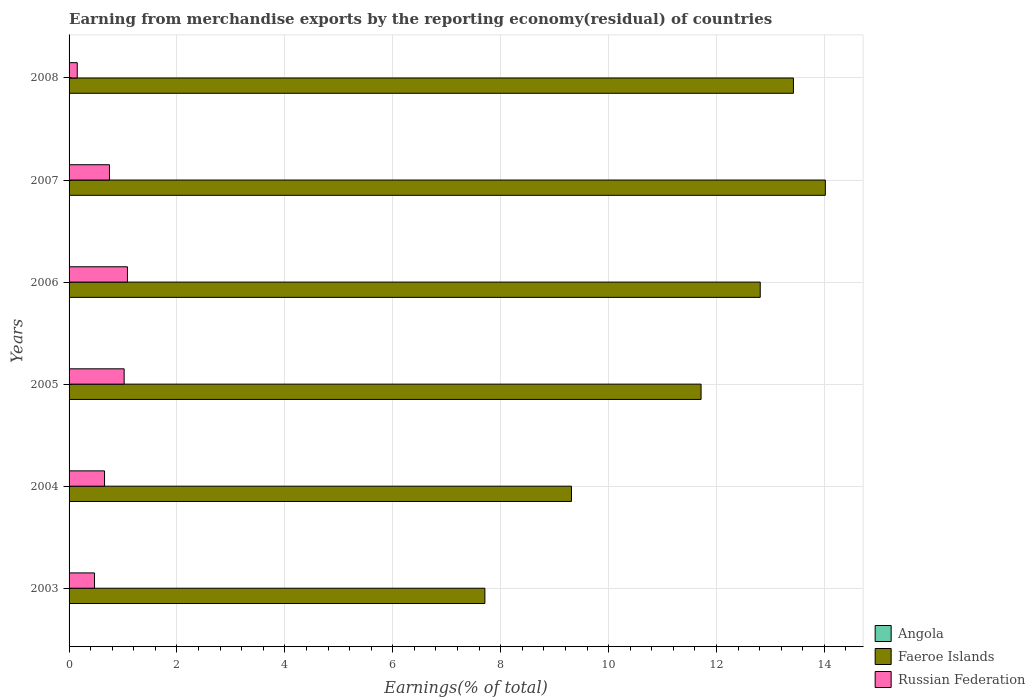Are the number of bars on each tick of the Y-axis equal?
Your response must be concise. No. How many bars are there on the 1st tick from the top?
Give a very brief answer. 3. How many bars are there on the 5th tick from the bottom?
Offer a terse response. 3. What is the label of the 6th group of bars from the top?
Your answer should be very brief. 2003. What is the percentage of amount earned from merchandise exports in Russian Federation in 2003?
Ensure brevity in your answer.  0.47. Across all years, what is the maximum percentage of amount earned from merchandise exports in Russian Federation?
Provide a short and direct response. 1.08. Across all years, what is the minimum percentage of amount earned from merchandise exports in Angola?
Your response must be concise. 0. What is the total percentage of amount earned from merchandise exports in Russian Federation in the graph?
Provide a succinct answer. 4.13. What is the difference between the percentage of amount earned from merchandise exports in Russian Federation in 2005 and that in 2008?
Keep it short and to the point. 0.87. What is the difference between the percentage of amount earned from merchandise exports in Faeroe Islands in 2006 and the percentage of amount earned from merchandise exports in Angola in 2007?
Your answer should be very brief. 12.81. What is the average percentage of amount earned from merchandise exports in Faeroe Islands per year?
Your answer should be compact. 11.5. In the year 2008, what is the difference between the percentage of amount earned from merchandise exports in Faeroe Islands and percentage of amount earned from merchandise exports in Russian Federation?
Keep it short and to the point. 13.27. What is the ratio of the percentage of amount earned from merchandise exports in Russian Federation in 2005 to that in 2006?
Ensure brevity in your answer.  0.94. What is the difference between the highest and the second highest percentage of amount earned from merchandise exports in Angola?
Give a very brief answer. 3.005684869051501e-10. What is the difference between the highest and the lowest percentage of amount earned from merchandise exports in Russian Federation?
Your response must be concise. 0.93. Are all the bars in the graph horizontal?
Provide a succinct answer. Yes. Where does the legend appear in the graph?
Keep it short and to the point. Bottom right. What is the title of the graph?
Make the answer very short. Earning from merchandise exports by the reporting economy(residual) of countries. Does "World" appear as one of the legend labels in the graph?
Ensure brevity in your answer.  No. What is the label or title of the X-axis?
Ensure brevity in your answer.  Earnings(% of total). What is the Earnings(% of total) of Faeroe Islands in 2003?
Provide a short and direct response. 7.71. What is the Earnings(% of total) of Russian Federation in 2003?
Your response must be concise. 0.47. What is the Earnings(% of total) of Angola in 2004?
Your response must be concise. 3.22232895644702e-9. What is the Earnings(% of total) in Faeroe Islands in 2004?
Give a very brief answer. 9.31. What is the Earnings(% of total) of Russian Federation in 2004?
Provide a succinct answer. 0.66. What is the Earnings(% of total) in Angola in 2005?
Your answer should be compact. 0. What is the Earnings(% of total) of Faeroe Islands in 2005?
Provide a succinct answer. 11.71. What is the Earnings(% of total) of Russian Federation in 2005?
Your response must be concise. 1.02. What is the Earnings(% of total) in Angola in 2006?
Provide a succinct answer. 0. What is the Earnings(% of total) of Faeroe Islands in 2006?
Offer a terse response. 12.81. What is the Earnings(% of total) of Russian Federation in 2006?
Provide a succinct answer. 1.08. What is the Earnings(% of total) of Angola in 2007?
Provide a succinct answer. 2.92176046954187e-9. What is the Earnings(% of total) of Faeroe Islands in 2007?
Your response must be concise. 14.02. What is the Earnings(% of total) in Russian Federation in 2007?
Make the answer very short. 0.75. What is the Earnings(% of total) of Angola in 2008?
Provide a short and direct response. 6.70973275053918e-10. What is the Earnings(% of total) of Faeroe Islands in 2008?
Ensure brevity in your answer.  13.43. What is the Earnings(% of total) of Russian Federation in 2008?
Your answer should be compact. 0.15. Across all years, what is the maximum Earnings(% of total) of Angola?
Provide a short and direct response. 3.22232895644702e-9. Across all years, what is the maximum Earnings(% of total) of Faeroe Islands?
Keep it short and to the point. 14.02. Across all years, what is the maximum Earnings(% of total) in Russian Federation?
Make the answer very short. 1.08. Across all years, what is the minimum Earnings(% of total) in Faeroe Islands?
Provide a succinct answer. 7.71. Across all years, what is the minimum Earnings(% of total) of Russian Federation?
Offer a terse response. 0.15. What is the total Earnings(% of total) in Angola in the graph?
Make the answer very short. 0. What is the total Earnings(% of total) of Faeroe Islands in the graph?
Provide a short and direct response. 68.99. What is the total Earnings(% of total) of Russian Federation in the graph?
Offer a terse response. 4.13. What is the difference between the Earnings(% of total) of Faeroe Islands in 2003 and that in 2004?
Keep it short and to the point. -1.6. What is the difference between the Earnings(% of total) of Russian Federation in 2003 and that in 2004?
Provide a short and direct response. -0.19. What is the difference between the Earnings(% of total) in Faeroe Islands in 2003 and that in 2005?
Your answer should be very brief. -4.01. What is the difference between the Earnings(% of total) of Russian Federation in 2003 and that in 2005?
Offer a very short reply. -0.55. What is the difference between the Earnings(% of total) of Faeroe Islands in 2003 and that in 2006?
Keep it short and to the point. -5.1. What is the difference between the Earnings(% of total) of Russian Federation in 2003 and that in 2006?
Provide a short and direct response. -0.61. What is the difference between the Earnings(% of total) in Faeroe Islands in 2003 and that in 2007?
Make the answer very short. -6.31. What is the difference between the Earnings(% of total) of Russian Federation in 2003 and that in 2007?
Keep it short and to the point. -0.28. What is the difference between the Earnings(% of total) of Faeroe Islands in 2003 and that in 2008?
Provide a succinct answer. -5.72. What is the difference between the Earnings(% of total) of Russian Federation in 2003 and that in 2008?
Your answer should be very brief. 0.32. What is the difference between the Earnings(% of total) of Faeroe Islands in 2004 and that in 2005?
Your response must be concise. -2.4. What is the difference between the Earnings(% of total) of Russian Federation in 2004 and that in 2005?
Make the answer very short. -0.36. What is the difference between the Earnings(% of total) in Faeroe Islands in 2004 and that in 2006?
Provide a short and direct response. -3.5. What is the difference between the Earnings(% of total) of Russian Federation in 2004 and that in 2006?
Your answer should be very brief. -0.42. What is the difference between the Earnings(% of total) of Angola in 2004 and that in 2007?
Make the answer very short. 0. What is the difference between the Earnings(% of total) of Faeroe Islands in 2004 and that in 2007?
Offer a very short reply. -4.71. What is the difference between the Earnings(% of total) of Russian Federation in 2004 and that in 2007?
Keep it short and to the point. -0.09. What is the difference between the Earnings(% of total) in Angola in 2004 and that in 2008?
Your answer should be very brief. 0. What is the difference between the Earnings(% of total) of Faeroe Islands in 2004 and that in 2008?
Keep it short and to the point. -4.11. What is the difference between the Earnings(% of total) of Russian Federation in 2004 and that in 2008?
Your response must be concise. 0.51. What is the difference between the Earnings(% of total) of Faeroe Islands in 2005 and that in 2006?
Offer a terse response. -1.1. What is the difference between the Earnings(% of total) of Russian Federation in 2005 and that in 2006?
Offer a terse response. -0.06. What is the difference between the Earnings(% of total) of Faeroe Islands in 2005 and that in 2007?
Provide a succinct answer. -2.3. What is the difference between the Earnings(% of total) in Russian Federation in 2005 and that in 2007?
Your response must be concise. 0.27. What is the difference between the Earnings(% of total) of Faeroe Islands in 2005 and that in 2008?
Make the answer very short. -1.71. What is the difference between the Earnings(% of total) in Russian Federation in 2005 and that in 2008?
Give a very brief answer. 0.87. What is the difference between the Earnings(% of total) in Faeroe Islands in 2006 and that in 2007?
Your answer should be compact. -1.21. What is the difference between the Earnings(% of total) of Russian Federation in 2006 and that in 2007?
Make the answer very short. 0.33. What is the difference between the Earnings(% of total) of Faeroe Islands in 2006 and that in 2008?
Give a very brief answer. -0.62. What is the difference between the Earnings(% of total) of Russian Federation in 2006 and that in 2008?
Offer a very short reply. 0.93. What is the difference between the Earnings(% of total) in Faeroe Islands in 2007 and that in 2008?
Ensure brevity in your answer.  0.59. What is the difference between the Earnings(% of total) of Russian Federation in 2007 and that in 2008?
Make the answer very short. 0.6. What is the difference between the Earnings(% of total) of Faeroe Islands in 2003 and the Earnings(% of total) of Russian Federation in 2004?
Provide a short and direct response. 7.05. What is the difference between the Earnings(% of total) of Faeroe Islands in 2003 and the Earnings(% of total) of Russian Federation in 2005?
Your response must be concise. 6.69. What is the difference between the Earnings(% of total) of Faeroe Islands in 2003 and the Earnings(% of total) of Russian Federation in 2006?
Your answer should be very brief. 6.63. What is the difference between the Earnings(% of total) of Faeroe Islands in 2003 and the Earnings(% of total) of Russian Federation in 2007?
Ensure brevity in your answer.  6.96. What is the difference between the Earnings(% of total) of Faeroe Islands in 2003 and the Earnings(% of total) of Russian Federation in 2008?
Give a very brief answer. 7.56. What is the difference between the Earnings(% of total) in Angola in 2004 and the Earnings(% of total) in Faeroe Islands in 2005?
Keep it short and to the point. -11.71. What is the difference between the Earnings(% of total) of Angola in 2004 and the Earnings(% of total) of Russian Federation in 2005?
Give a very brief answer. -1.02. What is the difference between the Earnings(% of total) in Faeroe Islands in 2004 and the Earnings(% of total) in Russian Federation in 2005?
Provide a succinct answer. 8.29. What is the difference between the Earnings(% of total) in Angola in 2004 and the Earnings(% of total) in Faeroe Islands in 2006?
Give a very brief answer. -12.81. What is the difference between the Earnings(% of total) in Angola in 2004 and the Earnings(% of total) in Russian Federation in 2006?
Keep it short and to the point. -1.08. What is the difference between the Earnings(% of total) of Faeroe Islands in 2004 and the Earnings(% of total) of Russian Federation in 2006?
Keep it short and to the point. 8.23. What is the difference between the Earnings(% of total) of Angola in 2004 and the Earnings(% of total) of Faeroe Islands in 2007?
Make the answer very short. -14.02. What is the difference between the Earnings(% of total) of Angola in 2004 and the Earnings(% of total) of Russian Federation in 2007?
Give a very brief answer. -0.75. What is the difference between the Earnings(% of total) in Faeroe Islands in 2004 and the Earnings(% of total) in Russian Federation in 2007?
Ensure brevity in your answer.  8.56. What is the difference between the Earnings(% of total) in Angola in 2004 and the Earnings(% of total) in Faeroe Islands in 2008?
Keep it short and to the point. -13.43. What is the difference between the Earnings(% of total) in Angola in 2004 and the Earnings(% of total) in Russian Federation in 2008?
Your answer should be compact. -0.15. What is the difference between the Earnings(% of total) in Faeroe Islands in 2004 and the Earnings(% of total) in Russian Federation in 2008?
Give a very brief answer. 9.16. What is the difference between the Earnings(% of total) of Faeroe Islands in 2005 and the Earnings(% of total) of Russian Federation in 2006?
Provide a short and direct response. 10.63. What is the difference between the Earnings(% of total) in Faeroe Islands in 2005 and the Earnings(% of total) in Russian Federation in 2007?
Offer a terse response. 10.97. What is the difference between the Earnings(% of total) in Faeroe Islands in 2005 and the Earnings(% of total) in Russian Federation in 2008?
Your response must be concise. 11.56. What is the difference between the Earnings(% of total) of Faeroe Islands in 2006 and the Earnings(% of total) of Russian Federation in 2007?
Give a very brief answer. 12.06. What is the difference between the Earnings(% of total) of Faeroe Islands in 2006 and the Earnings(% of total) of Russian Federation in 2008?
Your answer should be compact. 12.66. What is the difference between the Earnings(% of total) of Angola in 2007 and the Earnings(% of total) of Faeroe Islands in 2008?
Your response must be concise. -13.43. What is the difference between the Earnings(% of total) of Angola in 2007 and the Earnings(% of total) of Russian Federation in 2008?
Make the answer very short. -0.15. What is the difference between the Earnings(% of total) of Faeroe Islands in 2007 and the Earnings(% of total) of Russian Federation in 2008?
Provide a short and direct response. 13.87. What is the average Earnings(% of total) in Faeroe Islands per year?
Your response must be concise. 11.5. What is the average Earnings(% of total) in Russian Federation per year?
Your answer should be compact. 0.69. In the year 2003, what is the difference between the Earnings(% of total) in Faeroe Islands and Earnings(% of total) in Russian Federation?
Your answer should be compact. 7.24. In the year 2004, what is the difference between the Earnings(% of total) of Angola and Earnings(% of total) of Faeroe Islands?
Offer a terse response. -9.31. In the year 2004, what is the difference between the Earnings(% of total) in Angola and Earnings(% of total) in Russian Federation?
Provide a succinct answer. -0.66. In the year 2004, what is the difference between the Earnings(% of total) of Faeroe Islands and Earnings(% of total) of Russian Federation?
Make the answer very short. 8.65. In the year 2005, what is the difference between the Earnings(% of total) in Faeroe Islands and Earnings(% of total) in Russian Federation?
Ensure brevity in your answer.  10.69. In the year 2006, what is the difference between the Earnings(% of total) of Faeroe Islands and Earnings(% of total) of Russian Federation?
Keep it short and to the point. 11.73. In the year 2007, what is the difference between the Earnings(% of total) in Angola and Earnings(% of total) in Faeroe Islands?
Give a very brief answer. -14.02. In the year 2007, what is the difference between the Earnings(% of total) of Angola and Earnings(% of total) of Russian Federation?
Make the answer very short. -0.75. In the year 2007, what is the difference between the Earnings(% of total) of Faeroe Islands and Earnings(% of total) of Russian Federation?
Your answer should be compact. 13.27. In the year 2008, what is the difference between the Earnings(% of total) of Angola and Earnings(% of total) of Faeroe Islands?
Make the answer very short. -13.43. In the year 2008, what is the difference between the Earnings(% of total) in Angola and Earnings(% of total) in Russian Federation?
Ensure brevity in your answer.  -0.15. In the year 2008, what is the difference between the Earnings(% of total) of Faeroe Islands and Earnings(% of total) of Russian Federation?
Give a very brief answer. 13.27. What is the ratio of the Earnings(% of total) of Faeroe Islands in 2003 to that in 2004?
Offer a very short reply. 0.83. What is the ratio of the Earnings(% of total) in Russian Federation in 2003 to that in 2004?
Your answer should be compact. 0.72. What is the ratio of the Earnings(% of total) of Faeroe Islands in 2003 to that in 2005?
Make the answer very short. 0.66. What is the ratio of the Earnings(% of total) of Russian Federation in 2003 to that in 2005?
Ensure brevity in your answer.  0.46. What is the ratio of the Earnings(% of total) of Faeroe Islands in 2003 to that in 2006?
Offer a very short reply. 0.6. What is the ratio of the Earnings(% of total) of Russian Federation in 2003 to that in 2006?
Offer a very short reply. 0.44. What is the ratio of the Earnings(% of total) in Faeroe Islands in 2003 to that in 2007?
Give a very brief answer. 0.55. What is the ratio of the Earnings(% of total) in Russian Federation in 2003 to that in 2007?
Provide a short and direct response. 0.63. What is the ratio of the Earnings(% of total) of Faeroe Islands in 2003 to that in 2008?
Offer a very short reply. 0.57. What is the ratio of the Earnings(% of total) in Russian Federation in 2003 to that in 2008?
Provide a succinct answer. 3.11. What is the ratio of the Earnings(% of total) in Faeroe Islands in 2004 to that in 2005?
Offer a terse response. 0.79. What is the ratio of the Earnings(% of total) of Russian Federation in 2004 to that in 2005?
Your answer should be very brief. 0.64. What is the ratio of the Earnings(% of total) of Faeroe Islands in 2004 to that in 2006?
Your response must be concise. 0.73. What is the ratio of the Earnings(% of total) of Russian Federation in 2004 to that in 2006?
Make the answer very short. 0.61. What is the ratio of the Earnings(% of total) of Angola in 2004 to that in 2007?
Offer a very short reply. 1.1. What is the ratio of the Earnings(% of total) of Faeroe Islands in 2004 to that in 2007?
Provide a short and direct response. 0.66. What is the ratio of the Earnings(% of total) of Russian Federation in 2004 to that in 2007?
Ensure brevity in your answer.  0.88. What is the ratio of the Earnings(% of total) of Angola in 2004 to that in 2008?
Offer a terse response. 4.8. What is the ratio of the Earnings(% of total) of Faeroe Islands in 2004 to that in 2008?
Keep it short and to the point. 0.69. What is the ratio of the Earnings(% of total) in Russian Federation in 2004 to that in 2008?
Provide a short and direct response. 4.33. What is the ratio of the Earnings(% of total) of Faeroe Islands in 2005 to that in 2006?
Give a very brief answer. 0.91. What is the ratio of the Earnings(% of total) in Russian Federation in 2005 to that in 2006?
Provide a short and direct response. 0.94. What is the ratio of the Earnings(% of total) of Faeroe Islands in 2005 to that in 2007?
Ensure brevity in your answer.  0.84. What is the ratio of the Earnings(% of total) of Russian Federation in 2005 to that in 2007?
Keep it short and to the point. 1.36. What is the ratio of the Earnings(% of total) in Faeroe Islands in 2005 to that in 2008?
Your answer should be very brief. 0.87. What is the ratio of the Earnings(% of total) of Russian Federation in 2005 to that in 2008?
Your answer should be compact. 6.73. What is the ratio of the Earnings(% of total) of Faeroe Islands in 2006 to that in 2007?
Your response must be concise. 0.91. What is the ratio of the Earnings(% of total) of Russian Federation in 2006 to that in 2007?
Offer a terse response. 1.45. What is the ratio of the Earnings(% of total) of Faeroe Islands in 2006 to that in 2008?
Make the answer very short. 0.95. What is the ratio of the Earnings(% of total) of Russian Federation in 2006 to that in 2008?
Your answer should be very brief. 7.13. What is the ratio of the Earnings(% of total) of Angola in 2007 to that in 2008?
Your response must be concise. 4.35. What is the ratio of the Earnings(% of total) of Faeroe Islands in 2007 to that in 2008?
Give a very brief answer. 1.04. What is the ratio of the Earnings(% of total) in Russian Federation in 2007 to that in 2008?
Your response must be concise. 4.94. What is the difference between the highest and the second highest Earnings(% of total) of Faeroe Islands?
Provide a succinct answer. 0.59. What is the difference between the highest and the second highest Earnings(% of total) of Russian Federation?
Your response must be concise. 0.06. What is the difference between the highest and the lowest Earnings(% of total) in Angola?
Your answer should be compact. 0. What is the difference between the highest and the lowest Earnings(% of total) in Faeroe Islands?
Ensure brevity in your answer.  6.31. What is the difference between the highest and the lowest Earnings(% of total) of Russian Federation?
Your response must be concise. 0.93. 